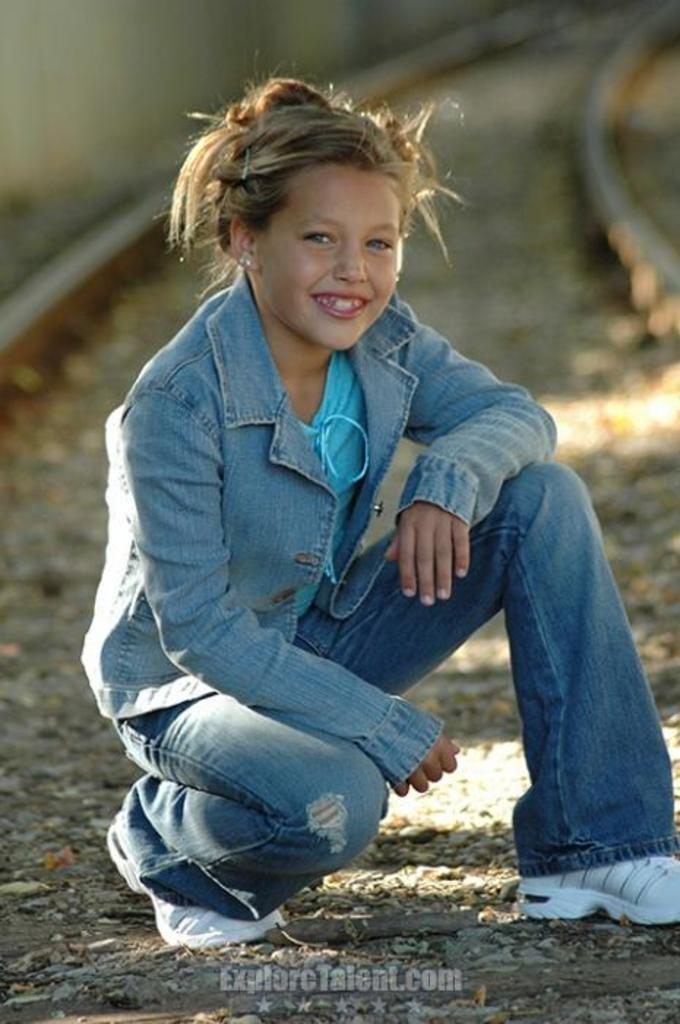Who is the main subject in the image? There is a girl in the image. What expression does the girl have? The girl is smiling. What can be seen in the background of the image? There are train tracks visible in the background of the image. What is present at the bottom of the image? There is text at the bottom of the image. What type of vest is the girl wearing in the image? There is no vest visible in the image; the girl is not wearing one. How many feet are present in the image? The number of feet cannot be determined from the image, as it only shows the girl and the background. 